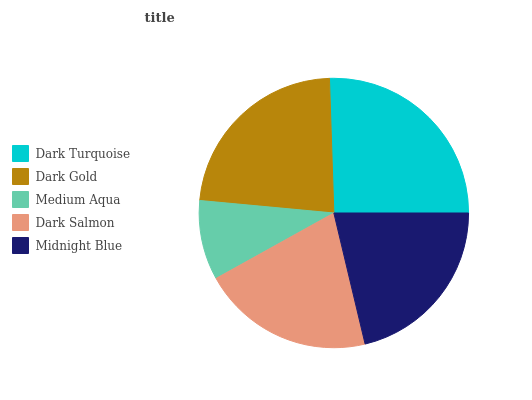Is Medium Aqua the minimum?
Answer yes or no. Yes. Is Dark Turquoise the maximum?
Answer yes or no. Yes. Is Dark Gold the minimum?
Answer yes or no. No. Is Dark Gold the maximum?
Answer yes or no. No. Is Dark Turquoise greater than Dark Gold?
Answer yes or no. Yes. Is Dark Gold less than Dark Turquoise?
Answer yes or no. Yes. Is Dark Gold greater than Dark Turquoise?
Answer yes or no. No. Is Dark Turquoise less than Dark Gold?
Answer yes or no. No. Is Midnight Blue the high median?
Answer yes or no. Yes. Is Midnight Blue the low median?
Answer yes or no. Yes. Is Dark Turquoise the high median?
Answer yes or no. No. Is Dark Gold the low median?
Answer yes or no. No. 